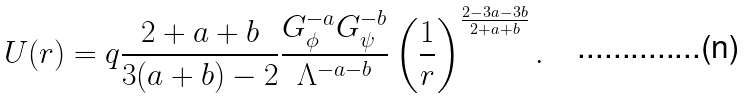Convert formula to latex. <formula><loc_0><loc_0><loc_500><loc_500>U ( r ) = q \frac { 2 + a + b } { 3 ( a + b ) - 2 } \frac { G ^ { - a } _ { \phi } G _ { \psi } ^ { - b } } { \Lambda ^ { - a - b } } \left ( \frac { 1 } { r } \right ) ^ { \frac { 2 - 3 a - 3 b } { 2 + a + b } } .</formula> 